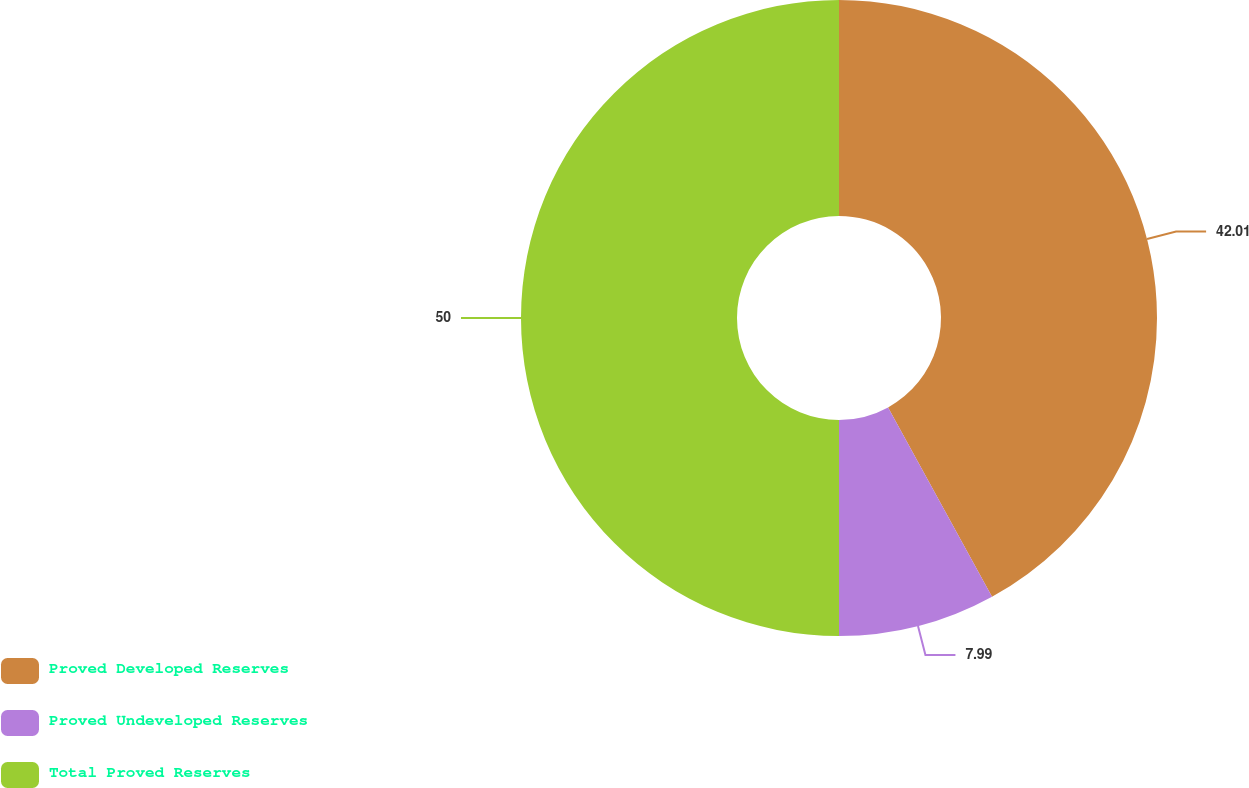Convert chart to OTSL. <chart><loc_0><loc_0><loc_500><loc_500><pie_chart><fcel>Proved Developed Reserves<fcel>Proved Undeveloped Reserves<fcel>Total Proved Reserves<nl><fcel>42.01%<fcel>7.99%<fcel>50.0%<nl></chart> 